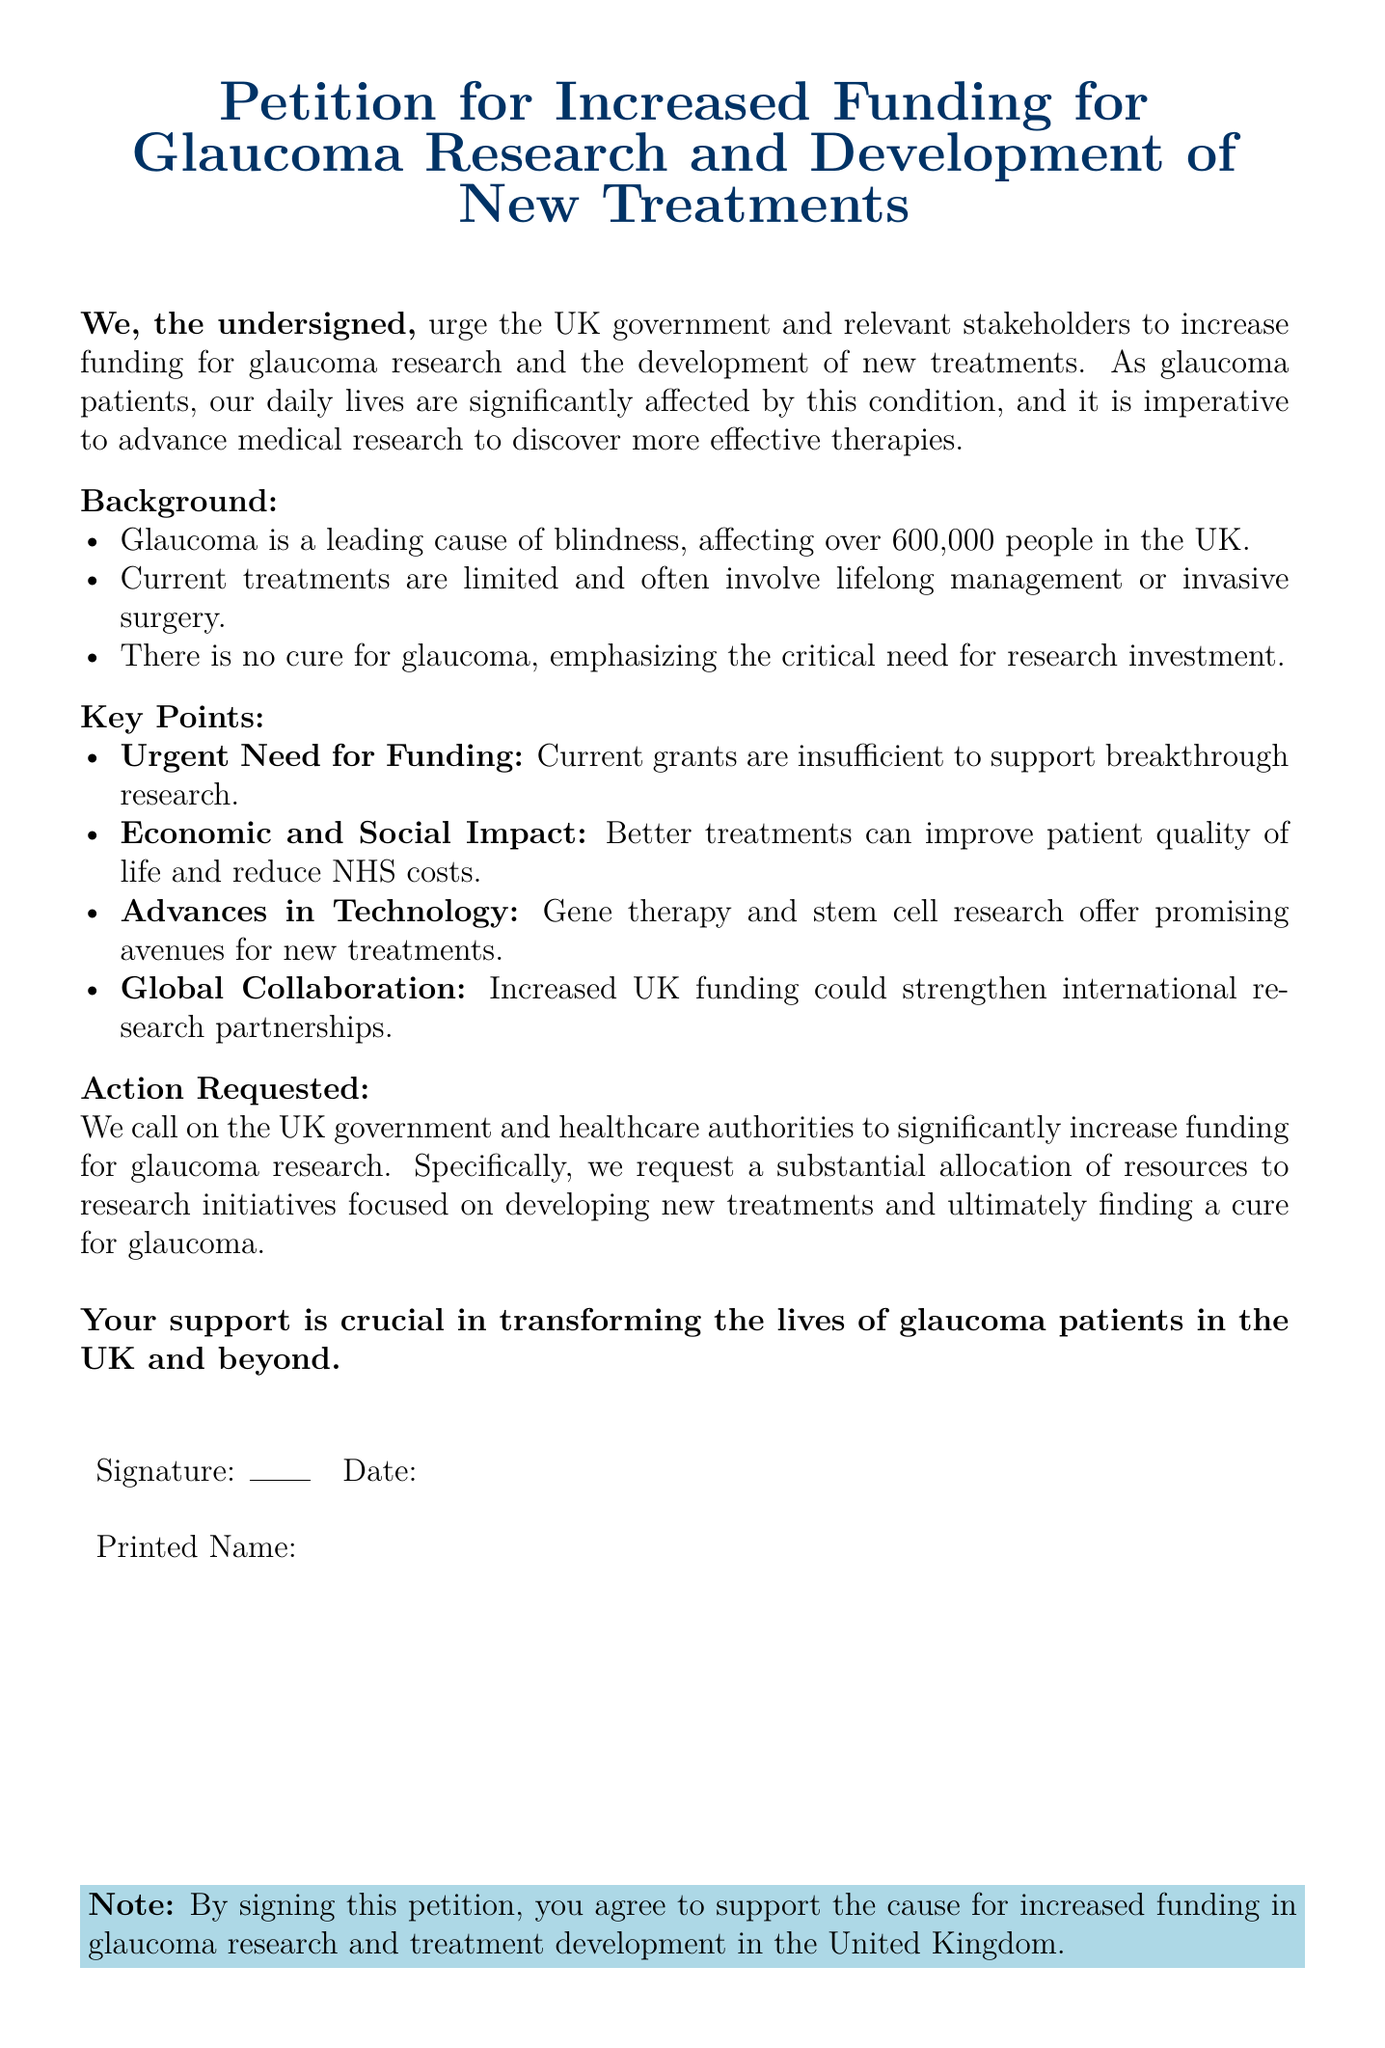What is the main purpose of the petition? The petition is urging for increased funding for glaucoma research and development of new treatments.
Answer: Increased funding for glaucoma research and development of new treatments How many people in the UK are affected by glaucoma? The document states that glaucoma affects over 600,000 people in the UK.
Answer: Over 600,000 people What type of therapies does the petition mention as a need for research? The petition mentions the need for more effective therapies for glaucoma.
Answer: More effective therapies What are the proposed promising avenues for new treatments mentioned? The petition highlights gene therapy and stem cell research as promising avenues.
Answer: Gene therapy and stem cell research What is the action requested by the signatories? The signatories request a substantial allocation of resources for research initiatives focused on glaucoma.
Answer: Substantial allocation of resources What does the petition suggest could improve patient quality of life? It suggests that better treatments could improve patient quality of life and reduce NHS costs.
Answer: Better treatments What color is used for the title in the petition? The title is highlighted in dark blue.
Answer: Dark blue What type of impacts are mentioned regarding insufficient funding for research? The impacts mentioned include economic and social impacts.
Answer: Economic and social impact 